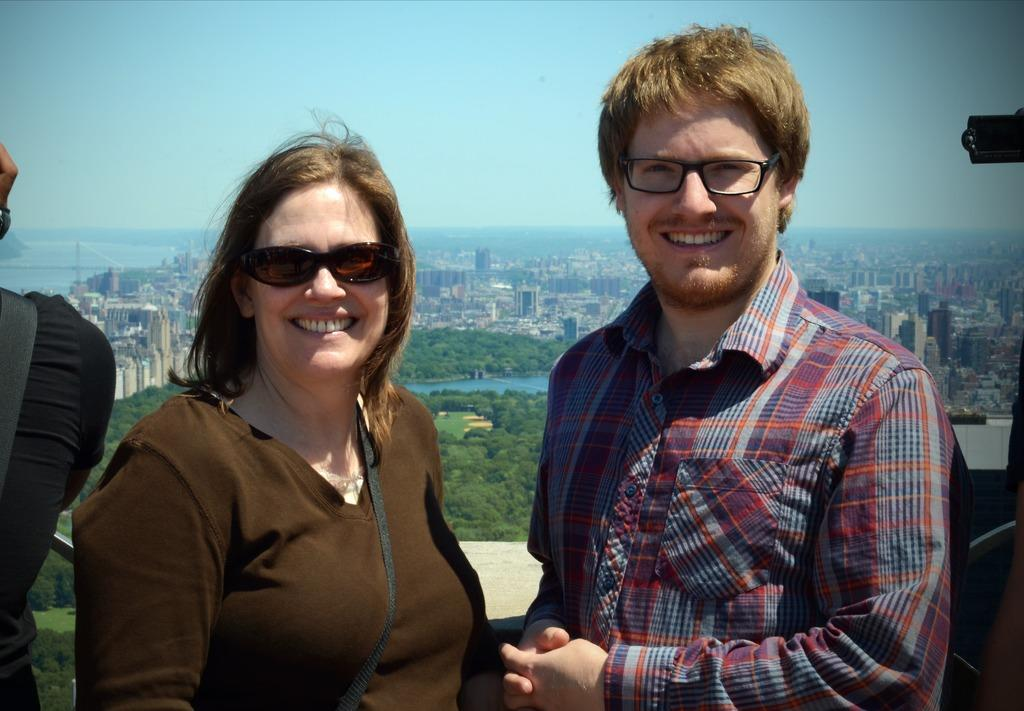How many people are in the image? There is a woman and a man in the image. What is the man wearing in the image? The man is wearing glasses in the image. What type of sunglasses is the woman wearing? The woman is wearing black sunglasses in the image. What can be seen in the background of the image? There are buildings, trees, and a river in the background of the image. What is the price of the boat in the image? There is no boat present in the image, so it is not possible to determine the price. 